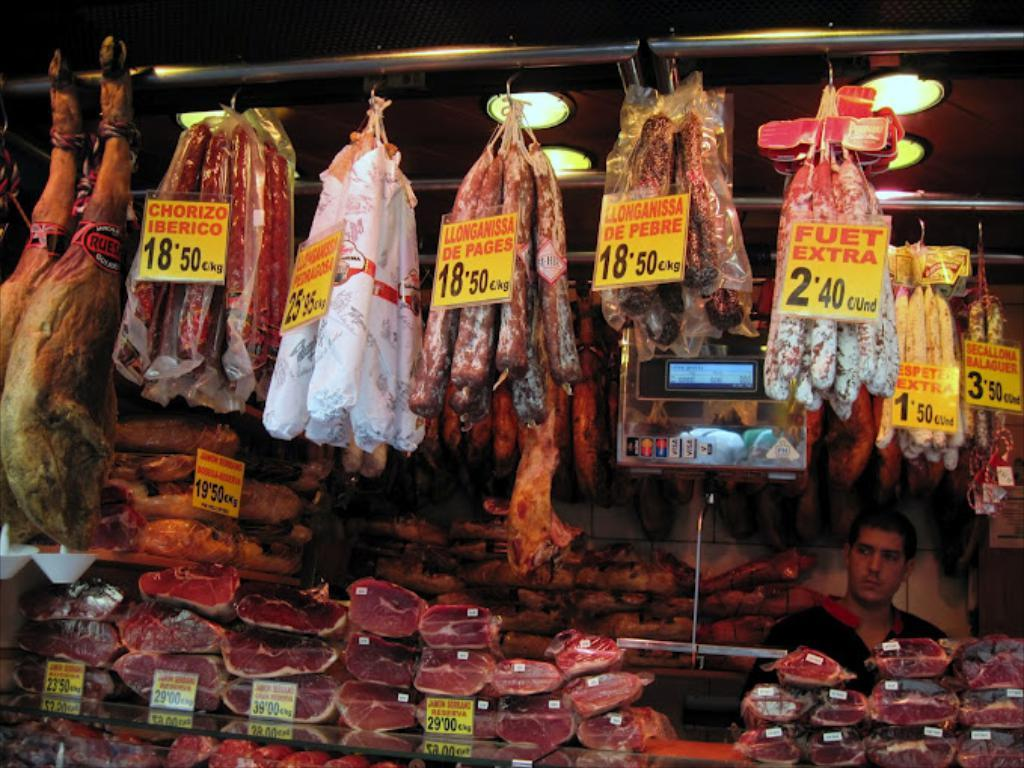What type of food can be seen in the image? There are meats in the image. How can the price of the items be determined? Price tags are present in the image. What device is used to weigh the items? A weighting price scale is visible in the image. What other objects are present in the image that are not specified? There are some unspecified objects in the image. What can be seen in the background of the image? There are rods and lights present in the background of the image. What type of popcorn is being prepared for the operation in the image? There is no popcorn or operation present in the image. 